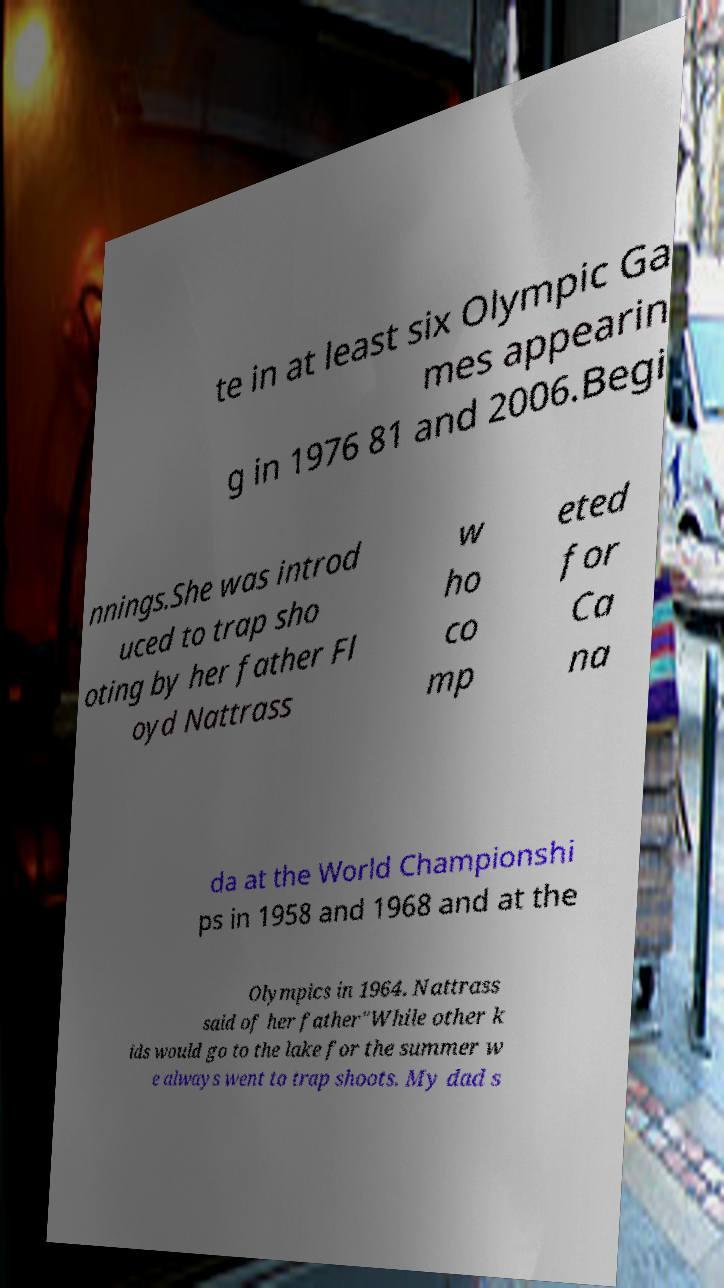Please read and relay the text visible in this image. What does it say? te in at least six Olympic Ga mes appearin g in 1976 81 and 2006.Begi nnings.She was introd uced to trap sho oting by her father Fl oyd Nattrass w ho co mp eted for Ca na da at the World Championshi ps in 1958 and 1968 and at the Olympics in 1964. Nattrass said of her father"While other k ids would go to the lake for the summer w e always went to trap shoots. My dad s 